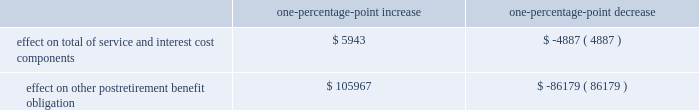The discount rate assumption was determined for the pension and postretirement benefit plans independently .
At year-end 2011 , the company began using an approach that approximates the process of settlement of obligations tailored to the plans 2019 expected cash flows by matching the plans 2019 cash flows to the coupons and expected maturity values of individually selected bonds .
The yield curve was developed for a universe containing the majority of u.s.-issued aa-graded corporate bonds , all of which were non callable ( or callable with make-whole provisions ) .
Historically , for each plan , the discount rate was developed as the level equivalent rate that would produce the same present value as that using spot rates aligned with the projected benefit payments .
The expected long-term rate of return on plan assets is based on historical and projected rates of return , prior to administrative and investment management fees , for current and planned asset classes in the plans 2019 investment portfolios .
Assumed projected rates of return for each of the plans 2019 projected asset classes were selected after analyzing historical experience and future expectations of the returns and volatility of the various asset classes .
Based on the target asset allocation for each asset class , the overall expected rate of return for the portfolio was developed , adjusted for historical and expected experience of active portfolio management results compared to the benchmark returns and for the effect of expenses paid from plan assets .
The company 2019s pension expense increases as the expected return on assets decreases .
In the determination of year end 2014 projected benefit plan obligations , the company adopted a new table based on the society of actuaries rp 2014 mortality table including a generational bb-2d projection scale .
The adoption resulted in a significant increase to pension and other postretirement benefit plans 2019 projected benefit obligations .
Assumed health care cost trend rates have a significant effect on the amounts reported for the other postretirement benefit plans .
The health care cost trend rate is based on historical rates and expected market conditions .
A one-percentage-point change in assumed health care cost trend rates would have the following effects : one-percentage-point increase one-percentage-point decrease effect on total of service and interest cost components .
$ 5943 $ ( 4887 ) effect on other postretirement benefit obligation .
$ 105967 $ ( 86179 ) .
The discount rate assumption was determined for the pension and postretirement benefit plans independently .
At year-end 2011 , the company began using an approach that approximates the process of settlement of obligations tailored to the plans 2019 expected cash flows by matching the plans 2019 cash flows to the coupons and expected maturity values of individually selected bonds .
The yield curve was developed for a universe containing the majority of u.s.-issued aa-graded corporate bonds , all of which were non callable ( or callable with make-whole provisions ) .
Historically , for each plan , the discount rate was developed as the level equivalent rate that would produce the same present value as that using spot rates aligned with the projected benefit payments .
The expected long-term rate of return on plan assets is based on historical and projected rates of return , prior to administrative and investment management fees , for current and planned asset classes in the plans 2019 investment portfolios .
Assumed projected rates of return for each of the plans 2019 projected asset classes were selected after analyzing historical experience and future expectations of the returns and volatility of the various asset classes .
Based on the target asset allocation for each asset class , the overall expected rate of return for the portfolio was developed , adjusted for historical and expected experience of active portfolio management results compared to the benchmark returns and for the effect of expenses paid from plan assets .
The company 2019s pension expense increases as the expected return on assets decreases .
In the determination of year end 2014 projected benefit plan obligations , the company adopted a new table based on the society of actuaries rp 2014 mortality table including a generational bb-2d projection scale .
The adoption resulted in a significant increase to pension and other postretirement benefit plans 2019 projected benefit obligations .
Assumed health care cost trend rates have a significant effect on the amounts reported for the other postretirement benefit plans .
The health care cost trend rate is based on historical rates and expected market conditions .
A one-percentage-point change in assumed health care cost trend rates would have the following effects : one-percentage-point increase one-percentage-point decrease effect on total of service and interest cost components .
$ 5943 $ ( 4887 ) effect on other postretirement benefit obligation .
$ 105967 $ ( 86179 ) .
What was the ratio of the increase in the service and cost components compared to other post retirement benefit obligation? 
Rationale: the ratio of the increase in dollars for service and costs compared to other post retirement benefit obligation was that for every 0.06 $ , 1.00 was spent in other post retirement benefit obligation
Computations: (5943 / 105967)
Answer: 0.05608. The discount rate assumption was determined for the pension and postretirement benefit plans independently .
At year-end 2011 , the company began using an approach that approximates the process of settlement of obligations tailored to the plans 2019 expected cash flows by matching the plans 2019 cash flows to the coupons and expected maturity values of individually selected bonds .
The yield curve was developed for a universe containing the majority of u.s.-issued aa-graded corporate bonds , all of which were non callable ( or callable with make-whole provisions ) .
Historically , for each plan , the discount rate was developed as the level equivalent rate that would produce the same present value as that using spot rates aligned with the projected benefit payments .
The expected long-term rate of return on plan assets is based on historical and projected rates of return , prior to administrative and investment management fees , for current and planned asset classes in the plans 2019 investment portfolios .
Assumed projected rates of return for each of the plans 2019 projected asset classes were selected after analyzing historical experience and future expectations of the returns and volatility of the various asset classes .
Based on the target asset allocation for each asset class , the overall expected rate of return for the portfolio was developed , adjusted for historical and expected experience of active portfolio management results compared to the benchmark returns and for the effect of expenses paid from plan assets .
The company 2019s pension expense increases as the expected return on assets decreases .
In the determination of year end 2014 projected benefit plan obligations , the company adopted a new table based on the society of actuaries rp 2014 mortality table including a generational bb-2d projection scale .
The adoption resulted in a significant increase to pension and other postretirement benefit plans 2019 projected benefit obligations .
Assumed health care cost trend rates have a significant effect on the amounts reported for the other postretirement benefit plans .
The health care cost trend rate is based on historical rates and expected market conditions .
A one-percentage-point change in assumed health care cost trend rates would have the following effects : one-percentage-point increase one-percentage-point decrease effect on total of service and interest cost components .
$ 5943 $ ( 4887 ) effect on other postretirement benefit obligation .
$ 105967 $ ( 86179 ) .
The discount rate assumption was determined for the pension and postretirement benefit plans independently .
At year-end 2011 , the company began using an approach that approximates the process of settlement of obligations tailored to the plans 2019 expected cash flows by matching the plans 2019 cash flows to the coupons and expected maturity values of individually selected bonds .
The yield curve was developed for a universe containing the majority of u.s.-issued aa-graded corporate bonds , all of which were non callable ( or callable with make-whole provisions ) .
Historically , for each plan , the discount rate was developed as the level equivalent rate that would produce the same present value as that using spot rates aligned with the projected benefit payments .
The expected long-term rate of return on plan assets is based on historical and projected rates of return , prior to administrative and investment management fees , for current and planned asset classes in the plans 2019 investment portfolios .
Assumed projected rates of return for each of the plans 2019 projected asset classes were selected after analyzing historical experience and future expectations of the returns and volatility of the various asset classes .
Based on the target asset allocation for each asset class , the overall expected rate of return for the portfolio was developed , adjusted for historical and expected experience of active portfolio management results compared to the benchmark returns and for the effect of expenses paid from plan assets .
The company 2019s pension expense increases as the expected return on assets decreases .
In the determination of year end 2014 projected benefit plan obligations , the company adopted a new table based on the society of actuaries rp 2014 mortality table including a generational bb-2d projection scale .
The adoption resulted in a significant increase to pension and other postretirement benefit plans 2019 projected benefit obligations .
Assumed health care cost trend rates have a significant effect on the amounts reported for the other postretirement benefit plans .
The health care cost trend rate is based on historical rates and expected market conditions .
A one-percentage-point change in assumed health care cost trend rates would have the following effects : one-percentage-point increase one-percentage-point decrease effect on total of service and interest cost components .
$ 5943 $ ( 4887 ) effect on other postretirement benefit obligation .
$ 105967 $ ( 86179 ) .
What was the net effect of the one percentage point change on the other post retirement benefit obligations combined? 
Rationale: the net effect on the other post retirement benefits is the sum of the decrease and increase
Computations: (105967 + -86179)
Answer: 19788.0. 